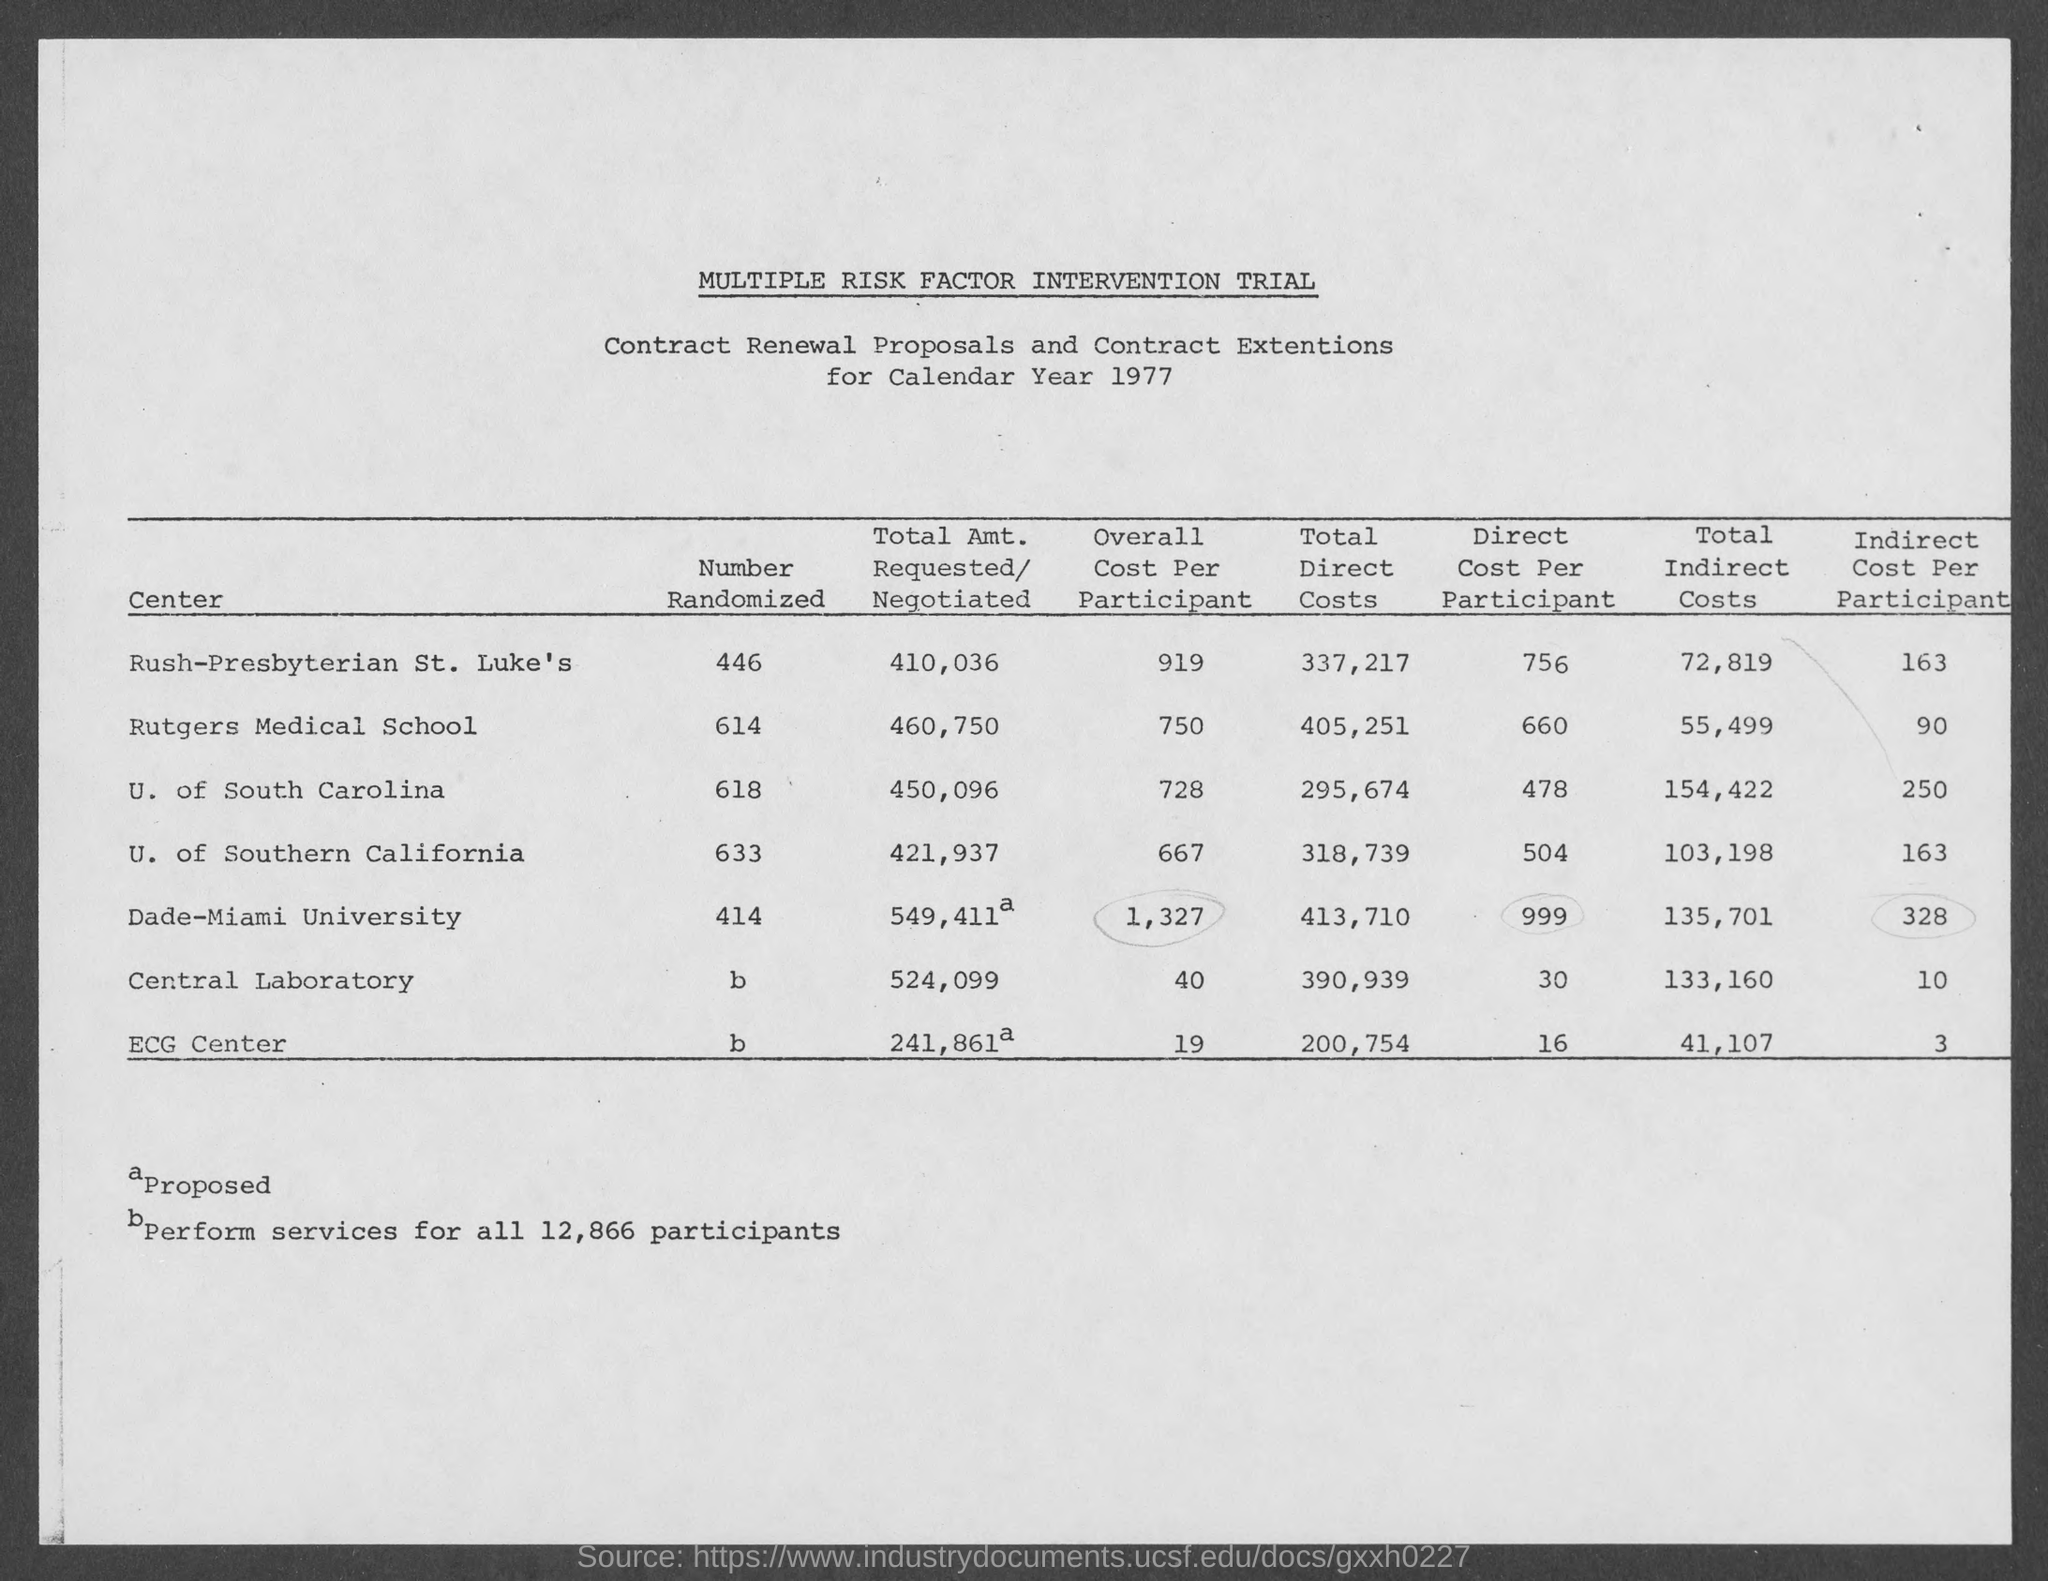Highlight a few significant elements in this photo. The number of randomized central laboratory tests conducted by our organization is [X]. The year mentioned in the document is 1977. The total direct cost for the central laboratory is 390,939. The total indirect cost for the ECG center is 41,107. The first title in the document is 'Multiple Risk Factor Intervention Trial.' 